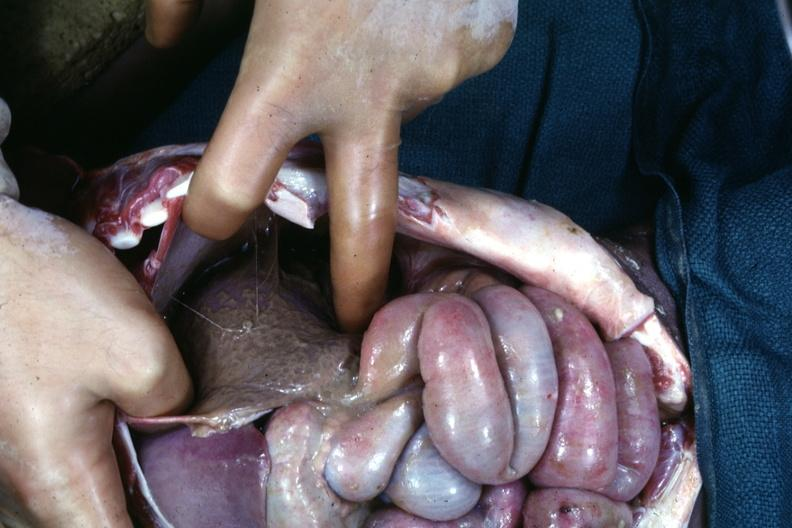what does this image show?
Answer the question using a single word or phrase. An opened peritoneal cavity cause by fibrous band strangulation see other slides 